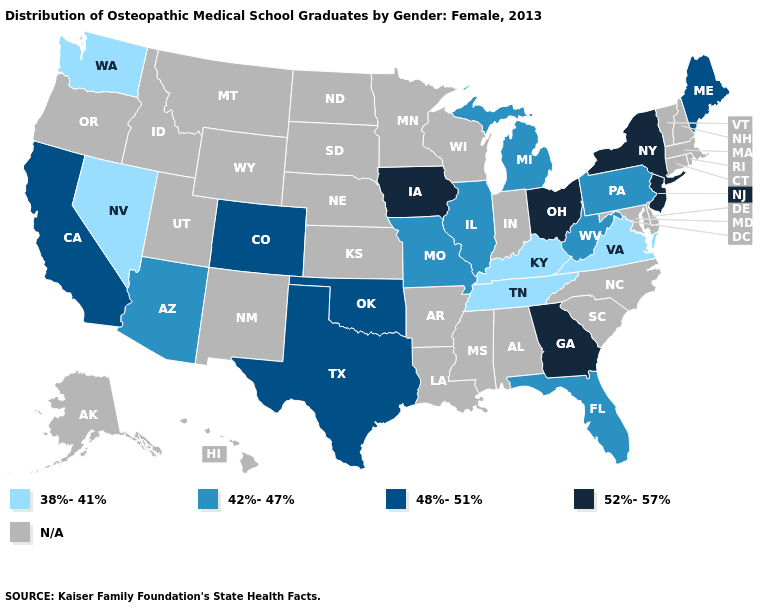Does Kentucky have the lowest value in the USA?
Answer briefly. Yes. Does the first symbol in the legend represent the smallest category?
Concise answer only. Yes. Does Nevada have the highest value in the West?
Give a very brief answer. No. Which states have the highest value in the USA?
Keep it brief. Georgia, Iowa, New Jersey, New York, Ohio. Which states hav the highest value in the MidWest?
Short answer required. Iowa, Ohio. What is the value of Hawaii?
Short answer required. N/A. Name the states that have a value in the range 48%-51%?
Short answer required. California, Colorado, Maine, Oklahoma, Texas. Name the states that have a value in the range 52%-57%?
Keep it brief. Georgia, Iowa, New Jersey, New York, Ohio. What is the value of Indiana?
Concise answer only. N/A. Among the states that border Alabama , does Tennessee have the lowest value?
Quick response, please. Yes. Name the states that have a value in the range N/A?
Be succinct. Alabama, Alaska, Arkansas, Connecticut, Delaware, Hawaii, Idaho, Indiana, Kansas, Louisiana, Maryland, Massachusetts, Minnesota, Mississippi, Montana, Nebraska, New Hampshire, New Mexico, North Carolina, North Dakota, Oregon, Rhode Island, South Carolina, South Dakota, Utah, Vermont, Wisconsin, Wyoming. Among the states that border Alabama , does Florida have the lowest value?
Short answer required. No. Among the states that border Virginia , does Tennessee have the lowest value?
Give a very brief answer. Yes. Does Iowa have the lowest value in the USA?
Keep it brief. No. 